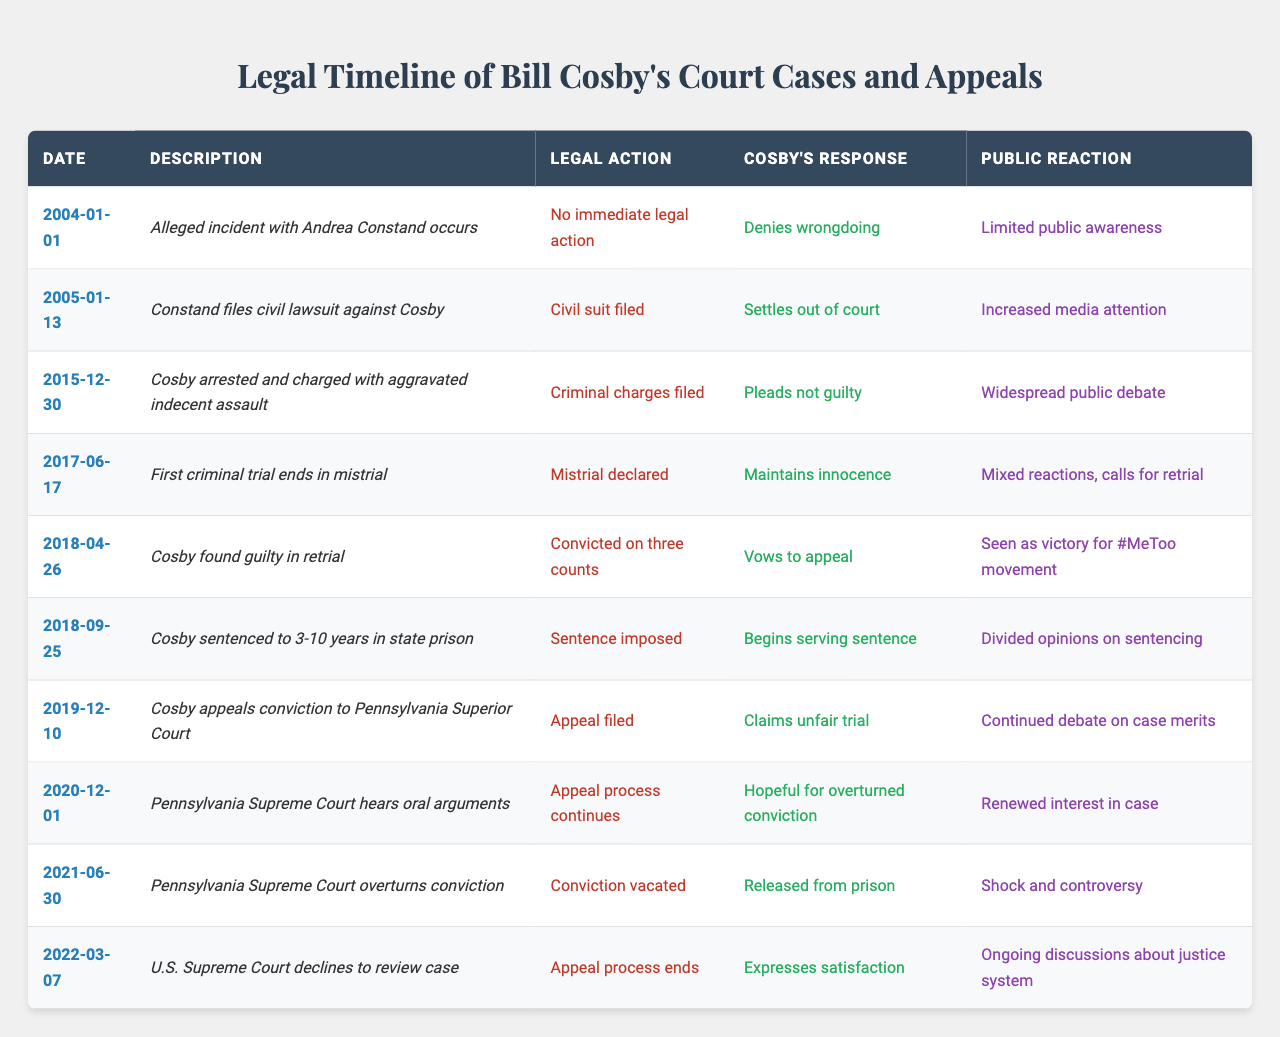What incident is alleged to have occurred with Andrea Constand? The table states that the alleged incident with Andrea Constand occurred on January 1, 2004.
Answer: Alleged incident with Andrea Constand What legal action was taken when the civil lawsuit was filed? According to the table, when Andrea Constand filed her civil lawsuit on January 13, 2005, the legal action taken was that a civil suit was filed.
Answer: Civil suit filed What was Bill Cosby's response after being found guilty in retrial? The table notes that after being found guilty on April 26, 2018, Bill Cosby vowed to appeal his conviction.
Answer: Vows to appeal When did Bill Cosby begin serving his prison sentence? The table indicates that Bill Cosby began serving his sentence on September 25, 2018, after being sentenced to 3-10 years.
Answer: September 25, 2018 How many counts was Bill Cosby convicted on? The table specifies that Bill Cosby was convicted on three counts during his retrial on April 26, 2018.
Answer: Three counts What was the public reaction to the overturning of Bill Cosby’s conviction? The table states that the public reaction to the Pennsylvania Supreme Court overturning his conviction on June 30, 2021, was one of shock and controversy.
Answer: Shock and controversy What year did the Pennsylvania Supreme Court hear oral arguments for Cosby's appeal? The table shows that the Pennsylvania Supreme Court heard oral arguments for Cosby's appeal on December 1, 2020.
Answer: 2020 What was the response of Bill Cosby after the U.S. Supreme Court declined to review his case? According to the table, Bill Cosby expressed satisfaction after the U.S. Supreme Court declined to review his case on March 7, 2022.
Answer: Expresses satisfaction How many significant legal actions occurred between 2015 and 2018? Between 2015 and 2018, significant legal actions include: criminal charges filed (2015), mistrial declared (2017), guilty verdict (2018), and sentencing (2018), totaling four significant legal actions.
Answer: Four Was there any immediate legal action taken in the incident of January 1, 2004? The table clearly states that there was no immediate legal action taken following the incident alleged on January 1, 2004.
Answer: No How did public reaction evolve from the initial incident to the final ruling by the Supreme Court? The public reaction evolved significantly; initial limited awareness (2004) increased media attention with the civil suit (2005), and culminated in shock and controversy when the conviction was overturned (2021). This indicates a growing interest and discussion about the case over time.
Answer: Evolved from limited awareness to shock and controversy What was the timeline of Bill Cosby's responses following legal actions against him from 2005 to 2021? Bill Cosby's responses followed a pattern: denied wrongdoing (2004), settled out of court (2005), pleaded not guilty (2015), maintained innocence (2017), vowed to appeal (2018), began serving sentence (2018), claimed unfair trial (2019), was hopeful for an overturned conviction (2020), and expressed satisfaction (2022). This illustrates a consistent strategy of denial, hope for justice, and later satisfaction.
Answer: Denial, settlement, innocence, vow to appeal, serving sentence, claim of unfair trial, hope, satisfaction What was the legal outcome for Bill Cosby after his appeal was filed in December 2019? After the appeal was filed in December 2019, the legal outcome was favorable for Bill Cosby, as the Pennsylvania Supreme Court vacated his conviction on June 30, 2021.
Answer: Conviction vacated 